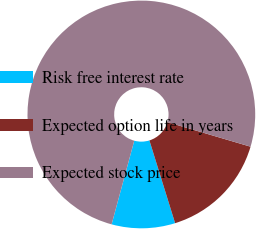<chart> <loc_0><loc_0><loc_500><loc_500><pie_chart><fcel>Risk free interest rate<fcel>Expected option life in years<fcel>Expected stock price<nl><fcel>9.0%<fcel>15.64%<fcel>75.37%<nl></chart> 